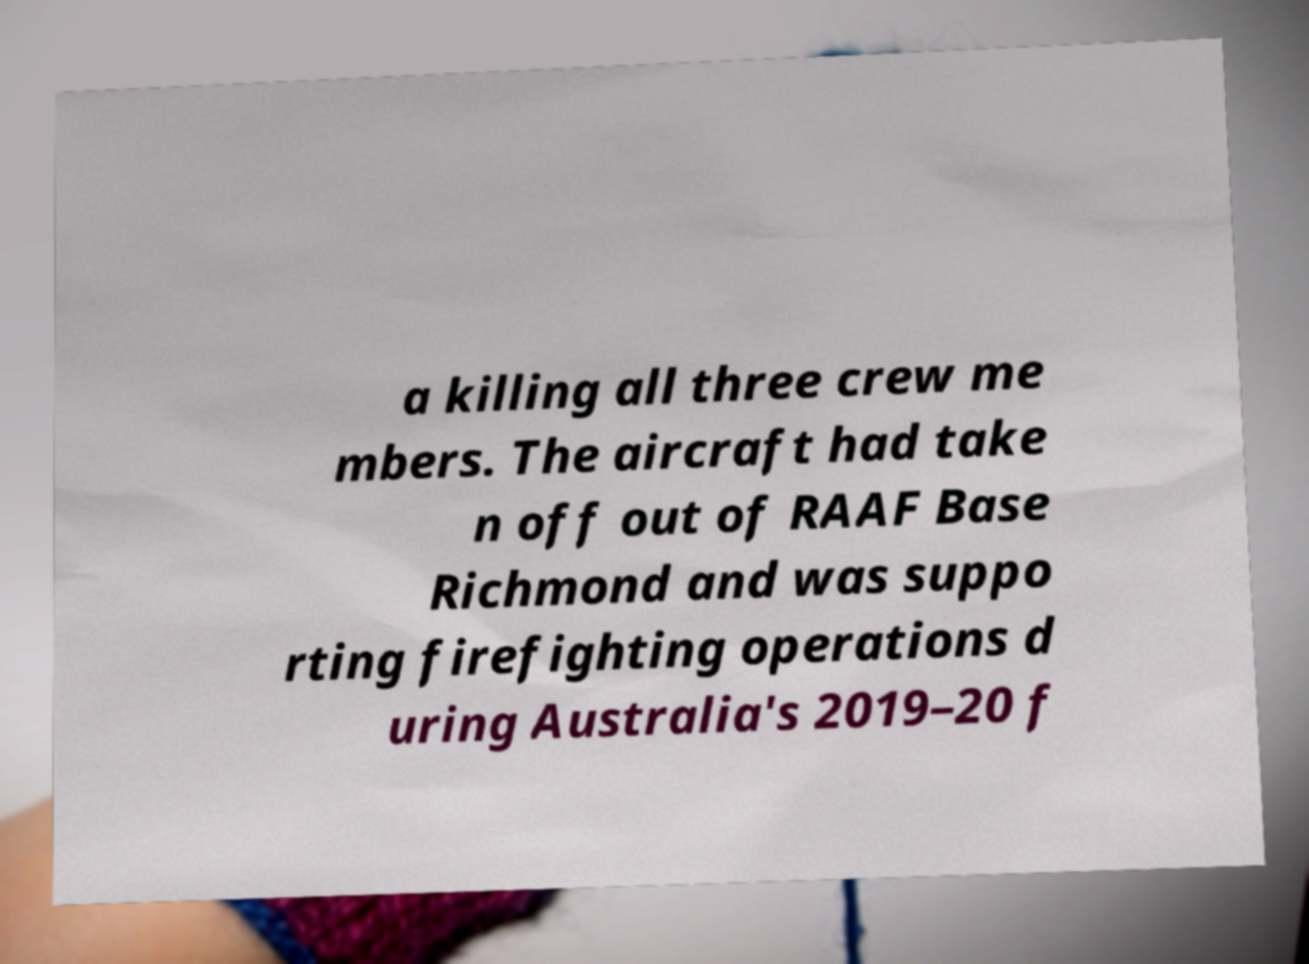I need the written content from this picture converted into text. Can you do that? a killing all three crew me mbers. The aircraft had take n off out of RAAF Base Richmond and was suppo rting firefighting operations d uring Australia's 2019–20 f 